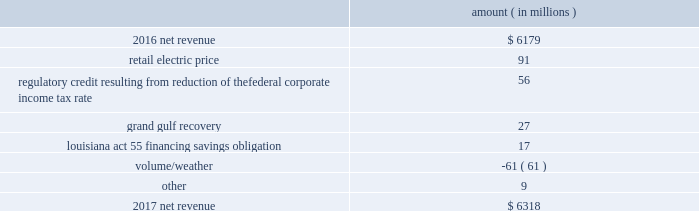Results of operations for 2016 include : 1 ) $ 2836 million ( $ 1829 million net-of-tax ) of impairment and related charges primarily to write down the carrying values of the entergy wholesale commodities 2019 palisades , indian point 2 , and indian point 3 plants and related assets to their fair values ; 2 ) a reduction of income tax expense , net of unrecognized tax benefits , of $ 238 million as a result of a change in the tax classification of a legal entity that owned one of the entergy wholesale commodities nuclear power plants ; income tax benefits as a result of the settlement of the 2010-2011 irs audit , including a $ 75 million tax benefit recognized by entergy louisiana related to the treatment of the vidalia purchased power agreement and a $ 54 million net benefit recognized by entergy louisiana related to the treatment of proceeds received in 2010 for the financing of hurricane gustav and hurricane ike storm costs pursuant to louisiana act 55 ; and 3 ) a reduction in expenses of $ 100 million ( $ 64 million net-of-tax ) due to the effects of recording in 2016 the final court decisions in several lawsuits against the doe related to spent nuclear fuel storage costs .
See note 14 to the financial statements for further discussion of the impairment and related charges , see note 3 to the financial statements for additional discussion of the income tax items , and see note 8 to the financial statements for discussion of the spent nuclear fuel litigation .
Net revenue utility following is an analysis of the change in net revenue comparing 2017 to 2016 .
Amount ( in millions ) .
The retail electric price variance is primarily due to : 2022 the implementation of formula rate plan rates effective with the first billing cycle of january 2017 at entergy arkansas and an increase in base rates effective february 24 , 2016 , each as approved by the apsc .
A significant portion of the base rate increase was related to the purchase of power block 2 of the union power station in march 2016 ; 2022 a provision recorded in 2016 related to the settlement of the waterford 3 replacement steam generator prudence review proceeding ; 2022 the implementation of the transmission cost recovery factor rider at entergy texas , effective september 2016 , and an increase in the transmission cost recovery factor rider rate , effective march 2017 , as approved by the puct ; and 2022 an increase in rates at entergy mississippi , as approved by the mpsc , effective with the first billing cycle of july 2016 .
See note 2 to the financial statements for further discussion of the rate proceedings and the waterford 3 replacement steam generator prudence review proceeding .
See note 14 to the financial statements for discussion of the union power station purchase .
Entergy corporation and subsidiaries management 2019s financial discussion and analysis .
In 2016 what was the tax rate on the income from the results of operations $ 2836 million 1829 million net-of-tax )? 
Computations: ((2836 - 1829) / 1829)
Answer: 0.55057. 